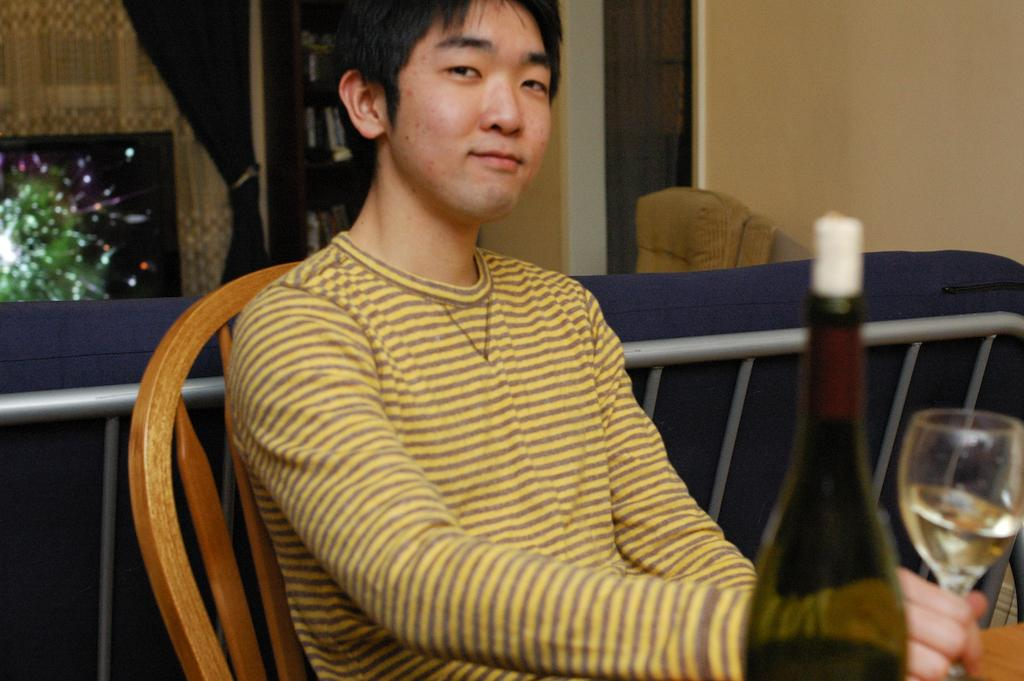What is the person in the image doing? The person is sitting on a chair and smiling. What is the person holding in the image? The person is holding a glass. What can be seen on the table in the image? There is a bottle and another glass on the table. What is visible in the background of the image? In the background, there is a TV, a sofa, a curtain, and a wall. What type of decision can be seen the person making in the image? There is no decision-making process visible in the image; the person is simply sitting and smiling. 